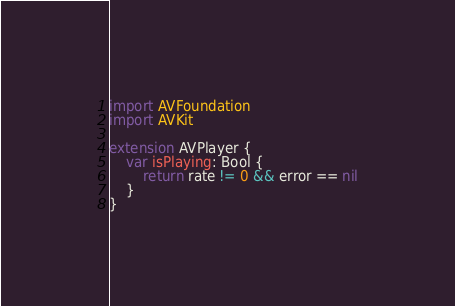<code> <loc_0><loc_0><loc_500><loc_500><_Swift_>import AVFoundation
import AVKit

extension AVPlayer {
    var isPlaying: Bool {
        return rate != 0 && error == nil
    }
}
</code> 